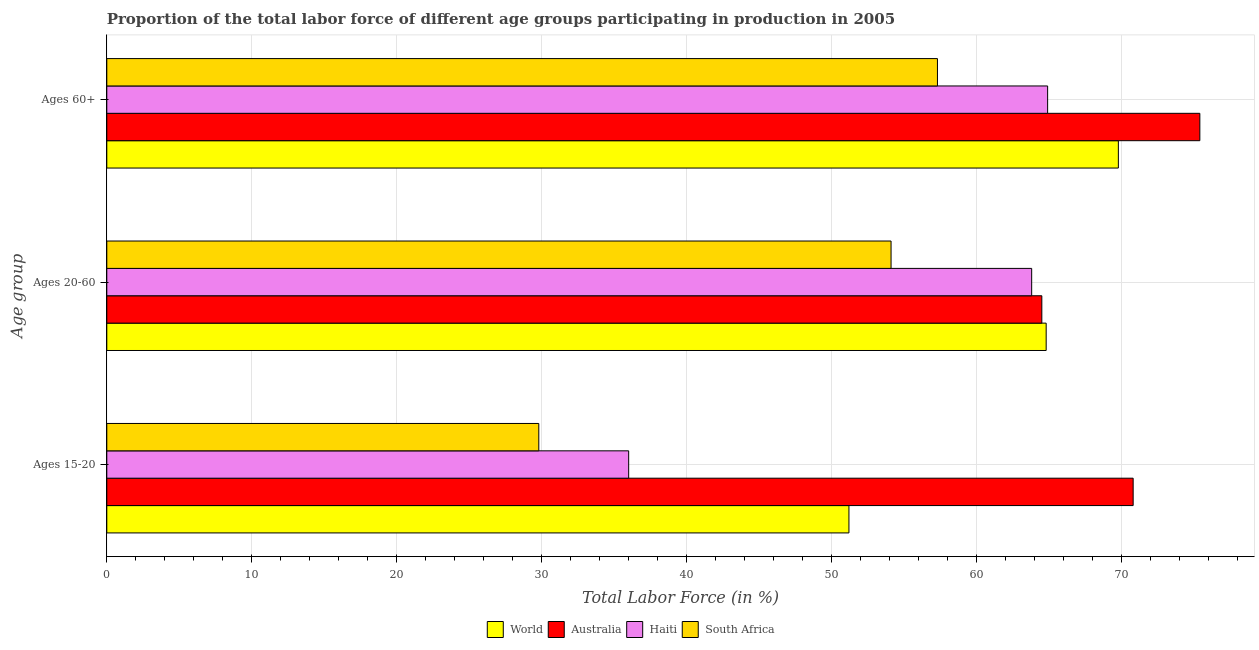How many groups of bars are there?
Make the answer very short. 3. Are the number of bars per tick equal to the number of legend labels?
Provide a succinct answer. Yes. How many bars are there on the 2nd tick from the top?
Provide a short and direct response. 4. How many bars are there on the 2nd tick from the bottom?
Your answer should be very brief. 4. What is the label of the 1st group of bars from the top?
Keep it short and to the point. Ages 60+. What is the percentage of labor force above age 60 in Australia?
Your response must be concise. 75.4. Across all countries, what is the maximum percentage of labor force above age 60?
Offer a terse response. 75.4. Across all countries, what is the minimum percentage of labor force within the age group 20-60?
Provide a succinct answer. 54.1. In which country was the percentage of labor force within the age group 15-20 minimum?
Your answer should be compact. South Africa. What is the total percentage of labor force within the age group 15-20 in the graph?
Your response must be concise. 187.79. What is the difference between the percentage of labor force above age 60 in Haiti and that in Australia?
Keep it short and to the point. -10.5. What is the difference between the percentage of labor force within the age group 20-60 in Australia and the percentage of labor force within the age group 15-20 in Haiti?
Give a very brief answer. 28.5. What is the average percentage of labor force within the age group 20-60 per country?
Your response must be concise. 61.8. What is the difference between the percentage of labor force above age 60 and percentage of labor force within the age group 20-60 in Haiti?
Provide a short and direct response. 1.1. What is the ratio of the percentage of labor force within the age group 20-60 in World to that in Haiti?
Ensure brevity in your answer.  1.02. Is the percentage of labor force above age 60 in World less than that in South Africa?
Make the answer very short. No. What is the difference between the highest and the second highest percentage of labor force within the age group 15-20?
Your response must be concise. 19.61. What is the difference between the highest and the lowest percentage of labor force within the age group 20-60?
Offer a terse response. 10.7. In how many countries, is the percentage of labor force within the age group 15-20 greater than the average percentage of labor force within the age group 15-20 taken over all countries?
Provide a succinct answer. 2. Is the sum of the percentage of labor force within the age group 20-60 in South Africa and Haiti greater than the maximum percentage of labor force within the age group 15-20 across all countries?
Provide a short and direct response. Yes. What does the 2nd bar from the top in Ages 60+ represents?
Keep it short and to the point. Haiti. What does the 3rd bar from the bottom in Ages 20-60 represents?
Your answer should be compact. Haiti. Is it the case that in every country, the sum of the percentage of labor force within the age group 15-20 and percentage of labor force within the age group 20-60 is greater than the percentage of labor force above age 60?
Offer a very short reply. Yes. Are the values on the major ticks of X-axis written in scientific E-notation?
Your answer should be very brief. No. Does the graph contain any zero values?
Ensure brevity in your answer.  No. Where does the legend appear in the graph?
Your answer should be compact. Bottom center. How many legend labels are there?
Offer a terse response. 4. How are the legend labels stacked?
Offer a terse response. Horizontal. What is the title of the graph?
Your answer should be very brief. Proportion of the total labor force of different age groups participating in production in 2005. What is the label or title of the Y-axis?
Give a very brief answer. Age group. What is the Total Labor Force (in %) of World in Ages 15-20?
Ensure brevity in your answer.  51.19. What is the Total Labor Force (in %) of Australia in Ages 15-20?
Your answer should be compact. 70.8. What is the Total Labor Force (in %) of Haiti in Ages 15-20?
Provide a succinct answer. 36. What is the Total Labor Force (in %) in South Africa in Ages 15-20?
Your response must be concise. 29.8. What is the Total Labor Force (in %) in World in Ages 20-60?
Your answer should be compact. 64.8. What is the Total Labor Force (in %) of Australia in Ages 20-60?
Provide a succinct answer. 64.5. What is the Total Labor Force (in %) of Haiti in Ages 20-60?
Offer a very short reply. 63.8. What is the Total Labor Force (in %) of South Africa in Ages 20-60?
Provide a succinct answer. 54.1. What is the Total Labor Force (in %) in World in Ages 60+?
Offer a terse response. 69.78. What is the Total Labor Force (in %) in Australia in Ages 60+?
Your response must be concise. 75.4. What is the Total Labor Force (in %) in Haiti in Ages 60+?
Provide a short and direct response. 64.9. What is the Total Labor Force (in %) of South Africa in Ages 60+?
Your response must be concise. 57.3. Across all Age group, what is the maximum Total Labor Force (in %) in World?
Your answer should be compact. 69.78. Across all Age group, what is the maximum Total Labor Force (in %) in Australia?
Provide a succinct answer. 75.4. Across all Age group, what is the maximum Total Labor Force (in %) in Haiti?
Your answer should be compact. 64.9. Across all Age group, what is the maximum Total Labor Force (in %) in South Africa?
Provide a short and direct response. 57.3. Across all Age group, what is the minimum Total Labor Force (in %) of World?
Give a very brief answer. 51.19. Across all Age group, what is the minimum Total Labor Force (in %) in Australia?
Offer a terse response. 64.5. Across all Age group, what is the minimum Total Labor Force (in %) in Haiti?
Your response must be concise. 36. Across all Age group, what is the minimum Total Labor Force (in %) of South Africa?
Offer a very short reply. 29.8. What is the total Total Labor Force (in %) in World in the graph?
Make the answer very short. 185.77. What is the total Total Labor Force (in %) of Australia in the graph?
Offer a terse response. 210.7. What is the total Total Labor Force (in %) in Haiti in the graph?
Offer a very short reply. 164.7. What is the total Total Labor Force (in %) in South Africa in the graph?
Make the answer very short. 141.2. What is the difference between the Total Labor Force (in %) in World in Ages 15-20 and that in Ages 20-60?
Keep it short and to the point. -13.61. What is the difference between the Total Labor Force (in %) of Haiti in Ages 15-20 and that in Ages 20-60?
Your answer should be very brief. -27.8. What is the difference between the Total Labor Force (in %) in South Africa in Ages 15-20 and that in Ages 20-60?
Ensure brevity in your answer.  -24.3. What is the difference between the Total Labor Force (in %) in World in Ages 15-20 and that in Ages 60+?
Your answer should be compact. -18.59. What is the difference between the Total Labor Force (in %) of Australia in Ages 15-20 and that in Ages 60+?
Ensure brevity in your answer.  -4.6. What is the difference between the Total Labor Force (in %) of Haiti in Ages 15-20 and that in Ages 60+?
Provide a short and direct response. -28.9. What is the difference between the Total Labor Force (in %) of South Africa in Ages 15-20 and that in Ages 60+?
Make the answer very short. -27.5. What is the difference between the Total Labor Force (in %) in World in Ages 20-60 and that in Ages 60+?
Make the answer very short. -4.98. What is the difference between the Total Labor Force (in %) of Australia in Ages 20-60 and that in Ages 60+?
Provide a succinct answer. -10.9. What is the difference between the Total Labor Force (in %) of South Africa in Ages 20-60 and that in Ages 60+?
Provide a short and direct response. -3.2. What is the difference between the Total Labor Force (in %) of World in Ages 15-20 and the Total Labor Force (in %) of Australia in Ages 20-60?
Provide a succinct answer. -13.31. What is the difference between the Total Labor Force (in %) of World in Ages 15-20 and the Total Labor Force (in %) of Haiti in Ages 20-60?
Provide a succinct answer. -12.61. What is the difference between the Total Labor Force (in %) in World in Ages 15-20 and the Total Labor Force (in %) in South Africa in Ages 20-60?
Ensure brevity in your answer.  -2.91. What is the difference between the Total Labor Force (in %) in Australia in Ages 15-20 and the Total Labor Force (in %) in Haiti in Ages 20-60?
Give a very brief answer. 7. What is the difference between the Total Labor Force (in %) in Australia in Ages 15-20 and the Total Labor Force (in %) in South Africa in Ages 20-60?
Provide a short and direct response. 16.7. What is the difference between the Total Labor Force (in %) of Haiti in Ages 15-20 and the Total Labor Force (in %) of South Africa in Ages 20-60?
Give a very brief answer. -18.1. What is the difference between the Total Labor Force (in %) of World in Ages 15-20 and the Total Labor Force (in %) of Australia in Ages 60+?
Ensure brevity in your answer.  -24.21. What is the difference between the Total Labor Force (in %) in World in Ages 15-20 and the Total Labor Force (in %) in Haiti in Ages 60+?
Keep it short and to the point. -13.71. What is the difference between the Total Labor Force (in %) of World in Ages 15-20 and the Total Labor Force (in %) of South Africa in Ages 60+?
Offer a very short reply. -6.11. What is the difference between the Total Labor Force (in %) in Australia in Ages 15-20 and the Total Labor Force (in %) in Haiti in Ages 60+?
Keep it short and to the point. 5.9. What is the difference between the Total Labor Force (in %) of Haiti in Ages 15-20 and the Total Labor Force (in %) of South Africa in Ages 60+?
Offer a very short reply. -21.3. What is the difference between the Total Labor Force (in %) of World in Ages 20-60 and the Total Labor Force (in %) of Australia in Ages 60+?
Provide a short and direct response. -10.6. What is the difference between the Total Labor Force (in %) in World in Ages 20-60 and the Total Labor Force (in %) in Haiti in Ages 60+?
Provide a succinct answer. -0.1. What is the difference between the Total Labor Force (in %) of World in Ages 20-60 and the Total Labor Force (in %) of South Africa in Ages 60+?
Provide a succinct answer. 7.5. What is the difference between the Total Labor Force (in %) of Australia in Ages 20-60 and the Total Labor Force (in %) of Haiti in Ages 60+?
Offer a terse response. -0.4. What is the average Total Labor Force (in %) in World per Age group?
Your response must be concise. 61.92. What is the average Total Labor Force (in %) in Australia per Age group?
Offer a terse response. 70.23. What is the average Total Labor Force (in %) in Haiti per Age group?
Provide a succinct answer. 54.9. What is the average Total Labor Force (in %) in South Africa per Age group?
Make the answer very short. 47.07. What is the difference between the Total Labor Force (in %) in World and Total Labor Force (in %) in Australia in Ages 15-20?
Provide a short and direct response. -19.61. What is the difference between the Total Labor Force (in %) in World and Total Labor Force (in %) in Haiti in Ages 15-20?
Make the answer very short. 15.19. What is the difference between the Total Labor Force (in %) of World and Total Labor Force (in %) of South Africa in Ages 15-20?
Offer a very short reply. 21.39. What is the difference between the Total Labor Force (in %) of Australia and Total Labor Force (in %) of Haiti in Ages 15-20?
Ensure brevity in your answer.  34.8. What is the difference between the Total Labor Force (in %) in Australia and Total Labor Force (in %) in South Africa in Ages 15-20?
Give a very brief answer. 41. What is the difference between the Total Labor Force (in %) in World and Total Labor Force (in %) in Australia in Ages 20-60?
Your response must be concise. 0.3. What is the difference between the Total Labor Force (in %) of World and Total Labor Force (in %) of Haiti in Ages 20-60?
Make the answer very short. 1. What is the difference between the Total Labor Force (in %) of World and Total Labor Force (in %) of South Africa in Ages 20-60?
Make the answer very short. 10.7. What is the difference between the Total Labor Force (in %) of World and Total Labor Force (in %) of Australia in Ages 60+?
Your answer should be compact. -5.62. What is the difference between the Total Labor Force (in %) of World and Total Labor Force (in %) of Haiti in Ages 60+?
Provide a short and direct response. 4.88. What is the difference between the Total Labor Force (in %) of World and Total Labor Force (in %) of South Africa in Ages 60+?
Offer a terse response. 12.48. What is the difference between the Total Labor Force (in %) of Australia and Total Labor Force (in %) of South Africa in Ages 60+?
Keep it short and to the point. 18.1. What is the difference between the Total Labor Force (in %) of Haiti and Total Labor Force (in %) of South Africa in Ages 60+?
Your response must be concise. 7.6. What is the ratio of the Total Labor Force (in %) of World in Ages 15-20 to that in Ages 20-60?
Your answer should be compact. 0.79. What is the ratio of the Total Labor Force (in %) of Australia in Ages 15-20 to that in Ages 20-60?
Provide a succinct answer. 1.1. What is the ratio of the Total Labor Force (in %) of Haiti in Ages 15-20 to that in Ages 20-60?
Offer a very short reply. 0.56. What is the ratio of the Total Labor Force (in %) of South Africa in Ages 15-20 to that in Ages 20-60?
Ensure brevity in your answer.  0.55. What is the ratio of the Total Labor Force (in %) of World in Ages 15-20 to that in Ages 60+?
Provide a succinct answer. 0.73. What is the ratio of the Total Labor Force (in %) of Australia in Ages 15-20 to that in Ages 60+?
Ensure brevity in your answer.  0.94. What is the ratio of the Total Labor Force (in %) of Haiti in Ages 15-20 to that in Ages 60+?
Your response must be concise. 0.55. What is the ratio of the Total Labor Force (in %) in South Africa in Ages 15-20 to that in Ages 60+?
Keep it short and to the point. 0.52. What is the ratio of the Total Labor Force (in %) of World in Ages 20-60 to that in Ages 60+?
Offer a terse response. 0.93. What is the ratio of the Total Labor Force (in %) of Australia in Ages 20-60 to that in Ages 60+?
Keep it short and to the point. 0.86. What is the ratio of the Total Labor Force (in %) of Haiti in Ages 20-60 to that in Ages 60+?
Offer a very short reply. 0.98. What is the ratio of the Total Labor Force (in %) in South Africa in Ages 20-60 to that in Ages 60+?
Provide a succinct answer. 0.94. What is the difference between the highest and the second highest Total Labor Force (in %) of World?
Offer a very short reply. 4.98. What is the difference between the highest and the second highest Total Labor Force (in %) of Australia?
Your response must be concise. 4.6. What is the difference between the highest and the second highest Total Labor Force (in %) in Haiti?
Your answer should be very brief. 1.1. What is the difference between the highest and the lowest Total Labor Force (in %) of World?
Offer a very short reply. 18.59. What is the difference between the highest and the lowest Total Labor Force (in %) of Australia?
Give a very brief answer. 10.9. What is the difference between the highest and the lowest Total Labor Force (in %) of Haiti?
Your answer should be compact. 28.9. 